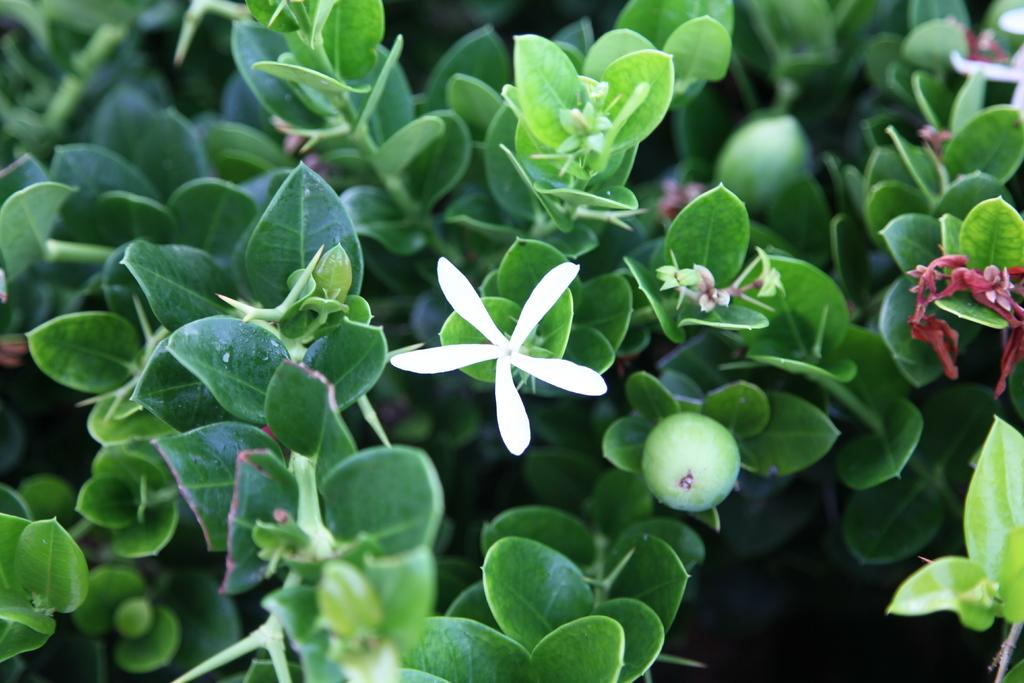What type of plant material can be seen in the image? There are leaves and flowers in the image. Can you describe the colors of the flowers? The colors of the flowers cannot be determined from the provided facts. What might be the purpose of the leaves in the image? The purpose of the leaves in the image cannot be determined from the provided facts. What type of shock can be seen in the image? There is no shock present in the image; it features leaves and flowers. What type of care is being provided to the wrist in the image? There is no wrist or care being provided in the image; it features leaves and flowers. 